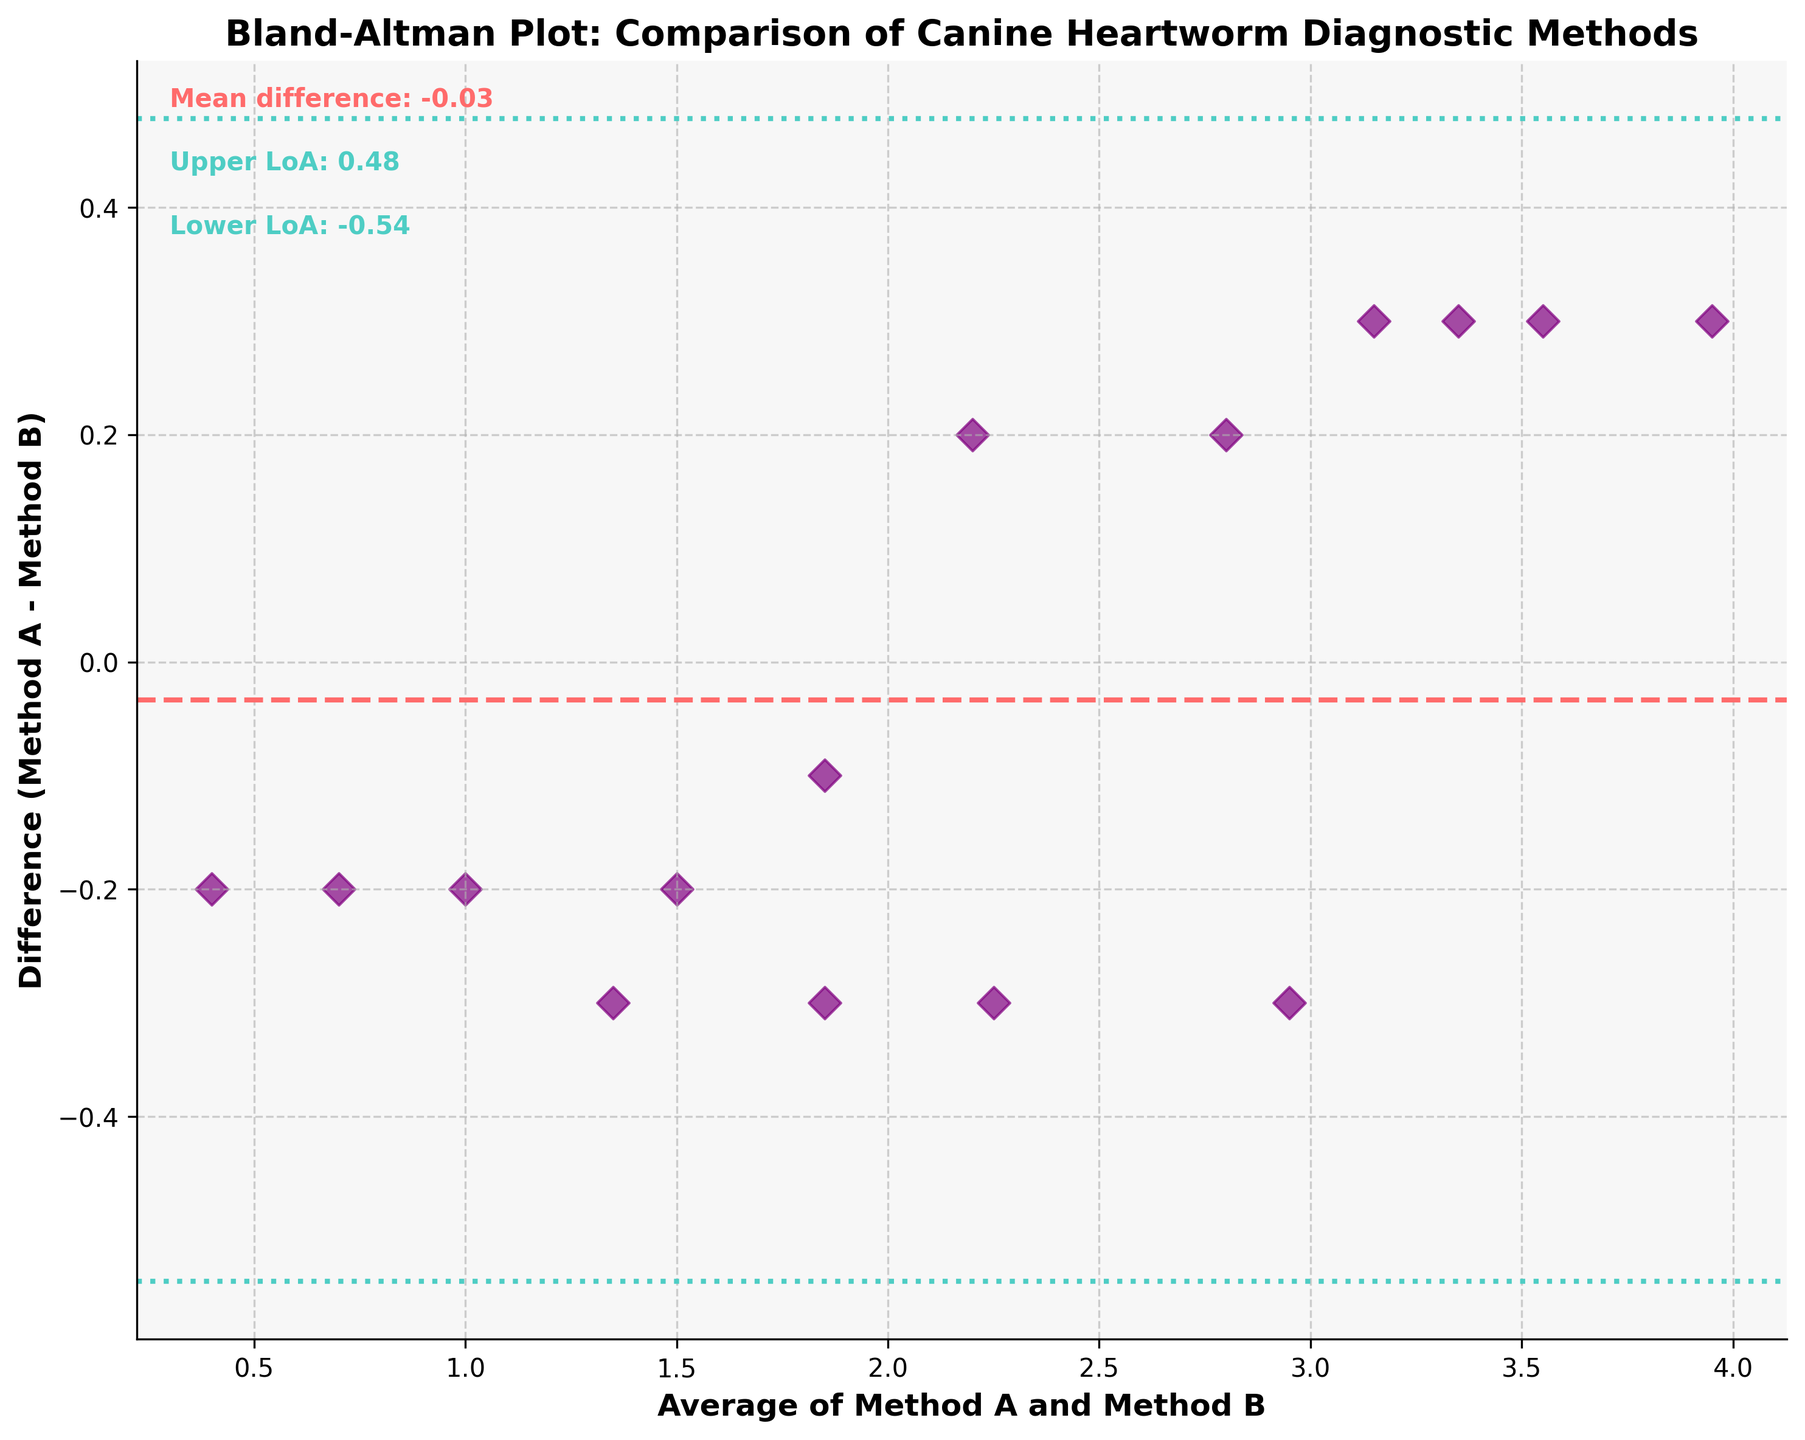What is the title of the figure? The title is located at the top of the figure. It usually provides an overall description of what the figure represents. In this case, it reads "Bland-Altman Plot: Comparison of Canine Heartworm Diagnostic Methods."
Answer: Bland-Altman Plot: Comparison of Canine Heartworm Diagnostic Methods How many data points are represented in the figure? Each data point in the Bland-Altman plot is represented by a scatter plot marker. By counting these markers, we can determine the number of data points.
Answer: 15 What is the main color of the data points on the plot? The data points in the scatter plot are depicted in a specific color, noted for visual emphasis. In this figure, they are purple.
Answer: Purple What is the mean difference as shown in the figure? The mean difference is typically indicated by a horizontal line, along with a textual annotation close to the line. It's shown as a red dashed line labeled "Mean difference: 0.10."
Answer: 0.10 What are the upper and lower limits of agreement? The limits of agreement are shown as two horizontal lines with textual annotations. The upper limit is annotated as "Upper LoA: 0.82," and the lower limit as "Lower LoA: -0.62."
Answer: Upper: 0.82, Lower: -0.62 What are the x-axis and y-axis representing? The x-axis and y-axis titles are usually captions describing what the axes represent. In this figure, the x-axis title is "Average of Method A and Method B," and the y-axis title is "Difference (Method A - Method B)."
Answer: x-axis: Average of Method A and Method B, y-axis: Difference (Method A - Method B) Calculate the range of the differences between Methods A and B. The differences for each data point are plotted on the y-axis. Observing the spread from lowest to highest difference values provides the range. The minimum is -0.2 and the maximum is 0.3 (approximated from the markers).
Answer: 0.5 Are there any data points falling outside the limits of agreement? By comparing the positions of data points with the horizontal lines representing the limits of agreement, we can see if any points fall outside these boundaries.
Answer: No How many data points lie above the mean difference line? Count the data points above the red dashed line representing the mean difference. This requires visual inspection of the plot.
Answer: 8 In which region (above or below) the mean difference do most data points lie? Compare the number of data points above the mean difference line to those below it. As counted, 8 points are above and 7 are below the mean difference line.
Answer: Above 